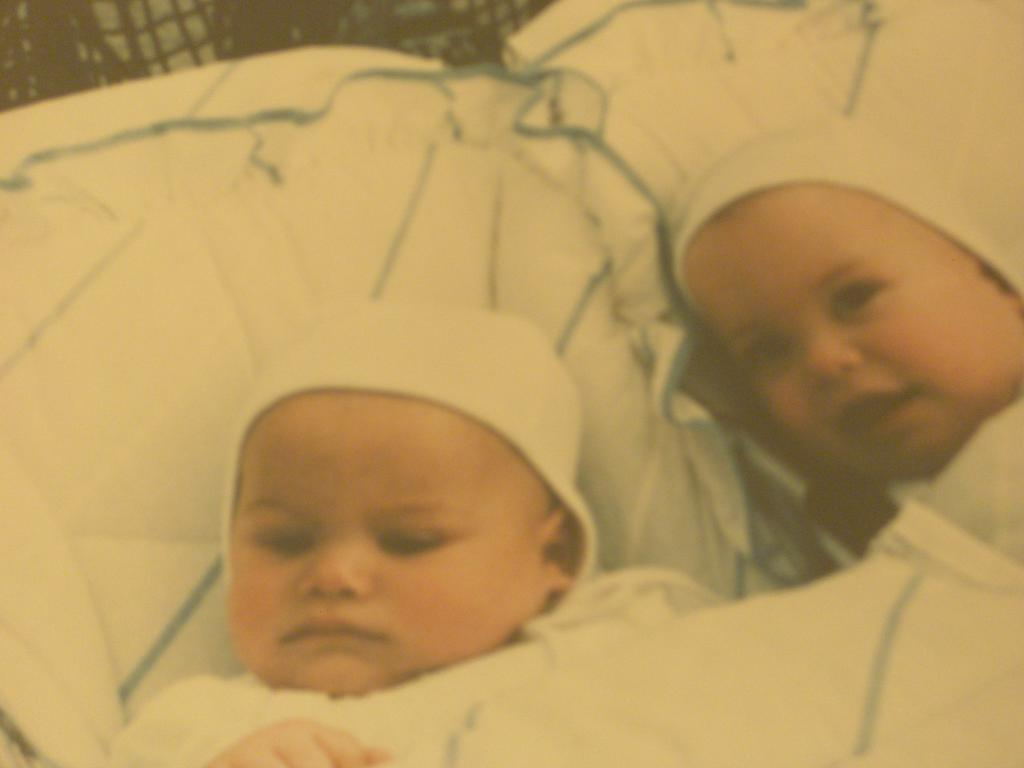How many babies are present in the image? There are two babies in the image. What are the babies laying on? The babies are laying on pillows. What type of shoe is the baby wearing on the stage in the image? There is no stage, shoe, or baby wearing a shoe in the image. The image only features two babies laying on pillows. 